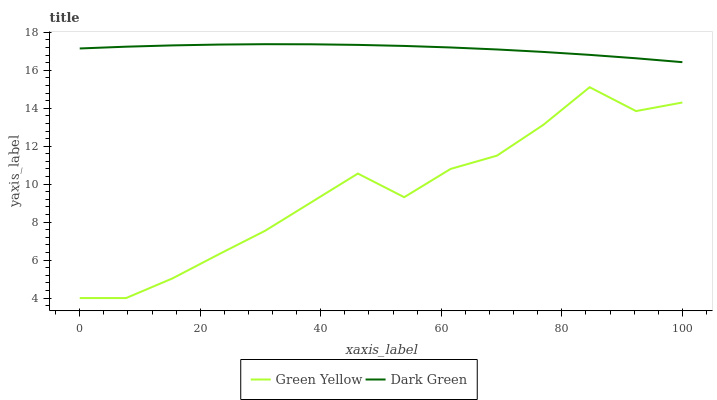Does Green Yellow have the minimum area under the curve?
Answer yes or no. Yes. Does Dark Green have the maximum area under the curve?
Answer yes or no. Yes. Does Dark Green have the minimum area under the curve?
Answer yes or no. No. Is Dark Green the smoothest?
Answer yes or no. Yes. Is Green Yellow the roughest?
Answer yes or no. Yes. Is Dark Green the roughest?
Answer yes or no. No. Does Green Yellow have the lowest value?
Answer yes or no. Yes. Does Dark Green have the lowest value?
Answer yes or no. No. Does Dark Green have the highest value?
Answer yes or no. Yes. Is Green Yellow less than Dark Green?
Answer yes or no. Yes. Is Dark Green greater than Green Yellow?
Answer yes or no. Yes. Does Green Yellow intersect Dark Green?
Answer yes or no. No. 